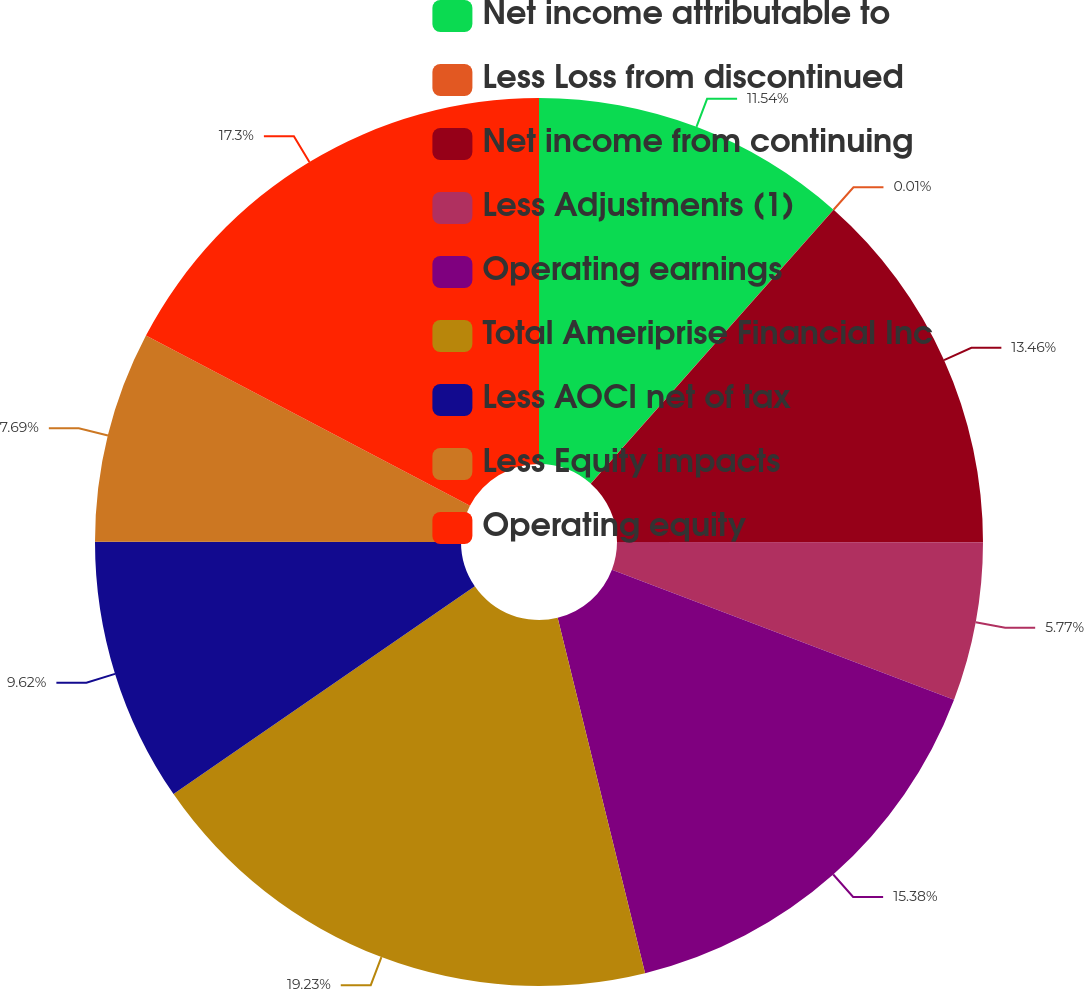Convert chart to OTSL. <chart><loc_0><loc_0><loc_500><loc_500><pie_chart><fcel>Net income attributable to<fcel>Less Loss from discontinued<fcel>Net income from continuing<fcel>Less Adjustments (1)<fcel>Operating earnings<fcel>Total Ameriprise Financial Inc<fcel>Less AOCI net of tax<fcel>Less Equity impacts<fcel>Operating equity<nl><fcel>11.54%<fcel>0.01%<fcel>13.46%<fcel>5.77%<fcel>15.38%<fcel>19.23%<fcel>9.62%<fcel>7.69%<fcel>17.3%<nl></chart> 